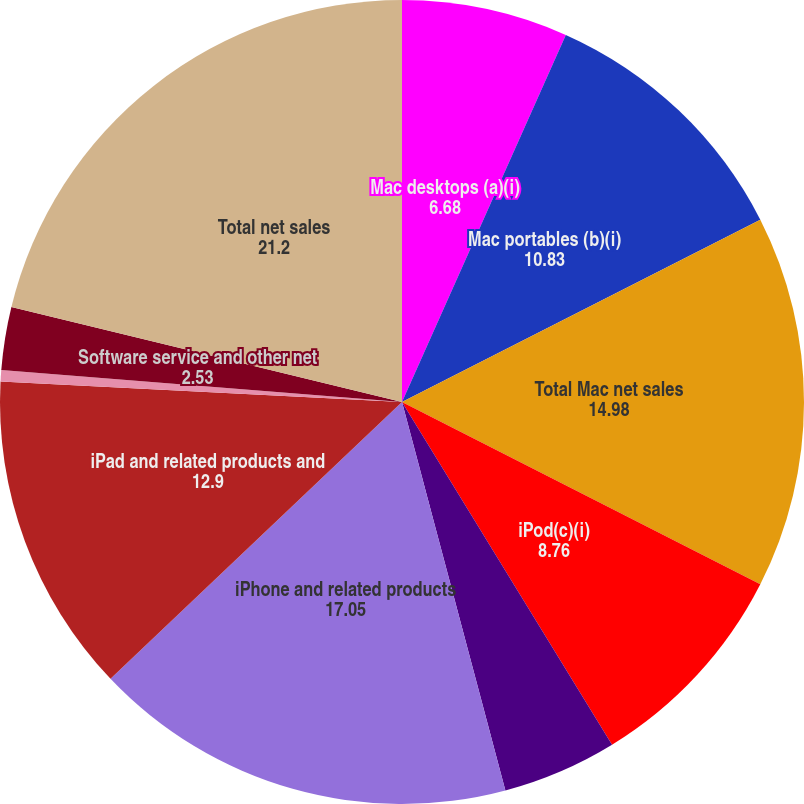<chart> <loc_0><loc_0><loc_500><loc_500><pie_chart><fcel>Mac desktops (a)(i)<fcel>Mac portables (b)(i)<fcel>Total Mac net sales<fcel>iPod(c)(i)<fcel>Other music related products<fcel>iPhone and related products<fcel>iPad and related products and<fcel>Peripherals and other hardware<fcel>Software service and other net<fcel>Total net sales<nl><fcel>6.68%<fcel>10.83%<fcel>14.98%<fcel>8.76%<fcel>4.61%<fcel>17.05%<fcel>12.9%<fcel>0.46%<fcel>2.53%<fcel>21.2%<nl></chart> 